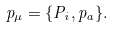<formula> <loc_0><loc_0><loc_500><loc_500>p _ { \mu } = \{ P _ { i } , p _ { a } \} .</formula> 